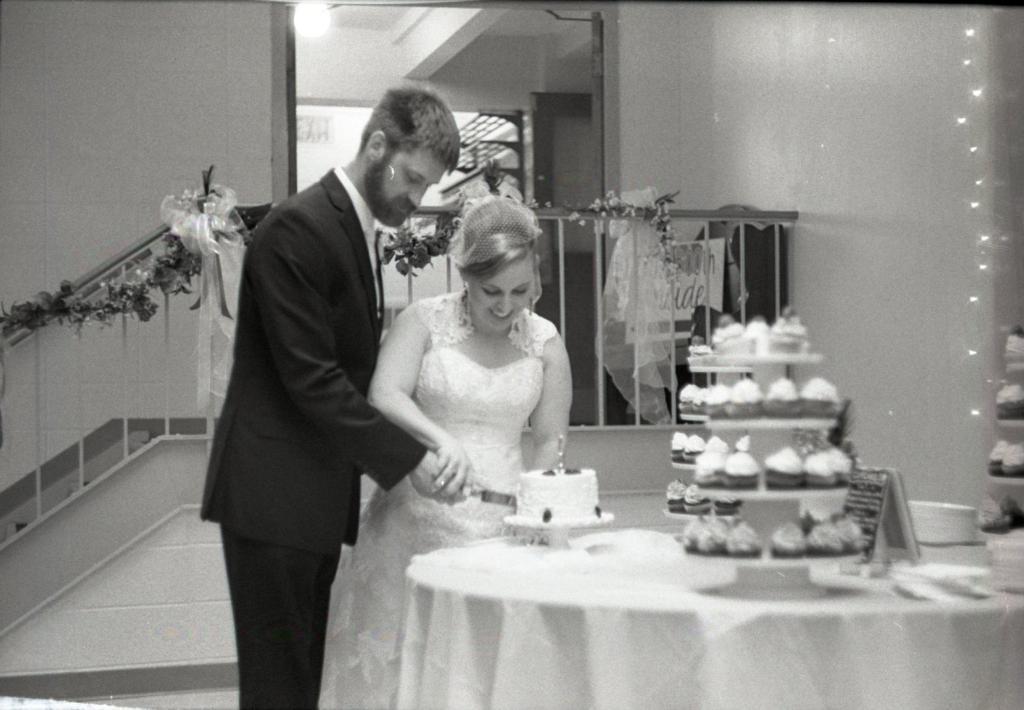In one or two sentences, can you explain what this image depicts? In the picture we can see a man and a woman standing together and cutting a cake which is on the table and beside the cake we can see a cake stand on it, we can see some cupcakes and in the background, we can see a railing and behind it we can see another room and to the ceiling we can see a light. 